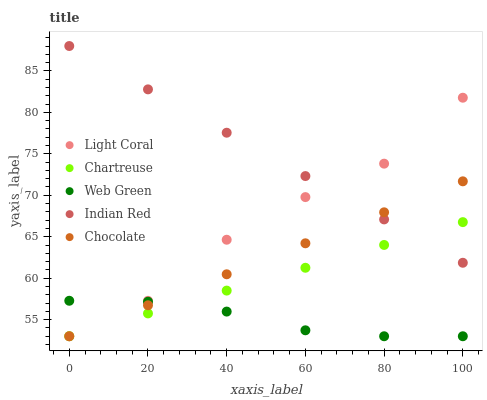Does Web Green have the minimum area under the curve?
Answer yes or no. Yes. Does Indian Red have the maximum area under the curve?
Answer yes or no. Yes. Does Chartreuse have the minimum area under the curve?
Answer yes or no. No. Does Chartreuse have the maximum area under the curve?
Answer yes or no. No. Is Chocolate the smoothest?
Answer yes or no. Yes. Is Light Coral the roughest?
Answer yes or no. Yes. Is Chartreuse the smoothest?
Answer yes or no. No. Is Chartreuse the roughest?
Answer yes or no. No. Does Light Coral have the lowest value?
Answer yes or no. Yes. Does Indian Red have the lowest value?
Answer yes or no. No. Does Indian Red have the highest value?
Answer yes or no. Yes. Does Chartreuse have the highest value?
Answer yes or no. No. Is Web Green less than Indian Red?
Answer yes or no. Yes. Is Indian Red greater than Web Green?
Answer yes or no. Yes. Does Indian Red intersect Chocolate?
Answer yes or no. Yes. Is Indian Red less than Chocolate?
Answer yes or no. No. Is Indian Red greater than Chocolate?
Answer yes or no. No. Does Web Green intersect Indian Red?
Answer yes or no. No. 